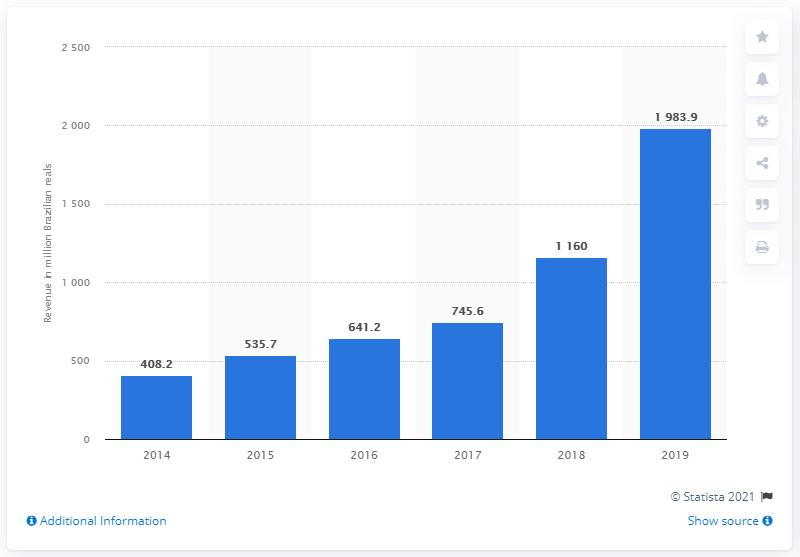Draw attention to some important aspects in this diagram. In 2014, Smartfit generated 408.2 Brazilian reals. In 2019, Smartfit generated 1,983.9 Brazilian reals. 